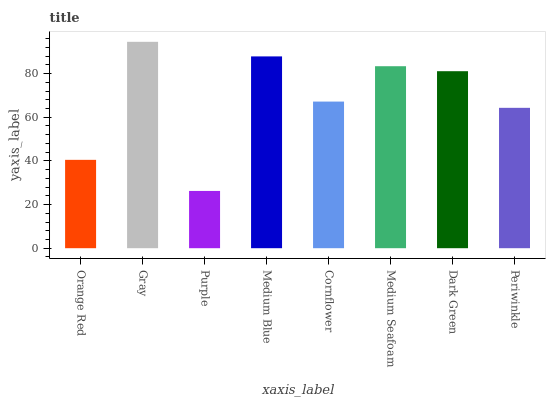Is Purple the minimum?
Answer yes or no. Yes. Is Gray the maximum?
Answer yes or no. Yes. Is Gray the minimum?
Answer yes or no. No. Is Purple the maximum?
Answer yes or no. No. Is Gray greater than Purple?
Answer yes or no. Yes. Is Purple less than Gray?
Answer yes or no. Yes. Is Purple greater than Gray?
Answer yes or no. No. Is Gray less than Purple?
Answer yes or no. No. Is Dark Green the high median?
Answer yes or no. Yes. Is Cornflower the low median?
Answer yes or no. Yes. Is Medium Blue the high median?
Answer yes or no. No. Is Medium Seafoam the low median?
Answer yes or no. No. 